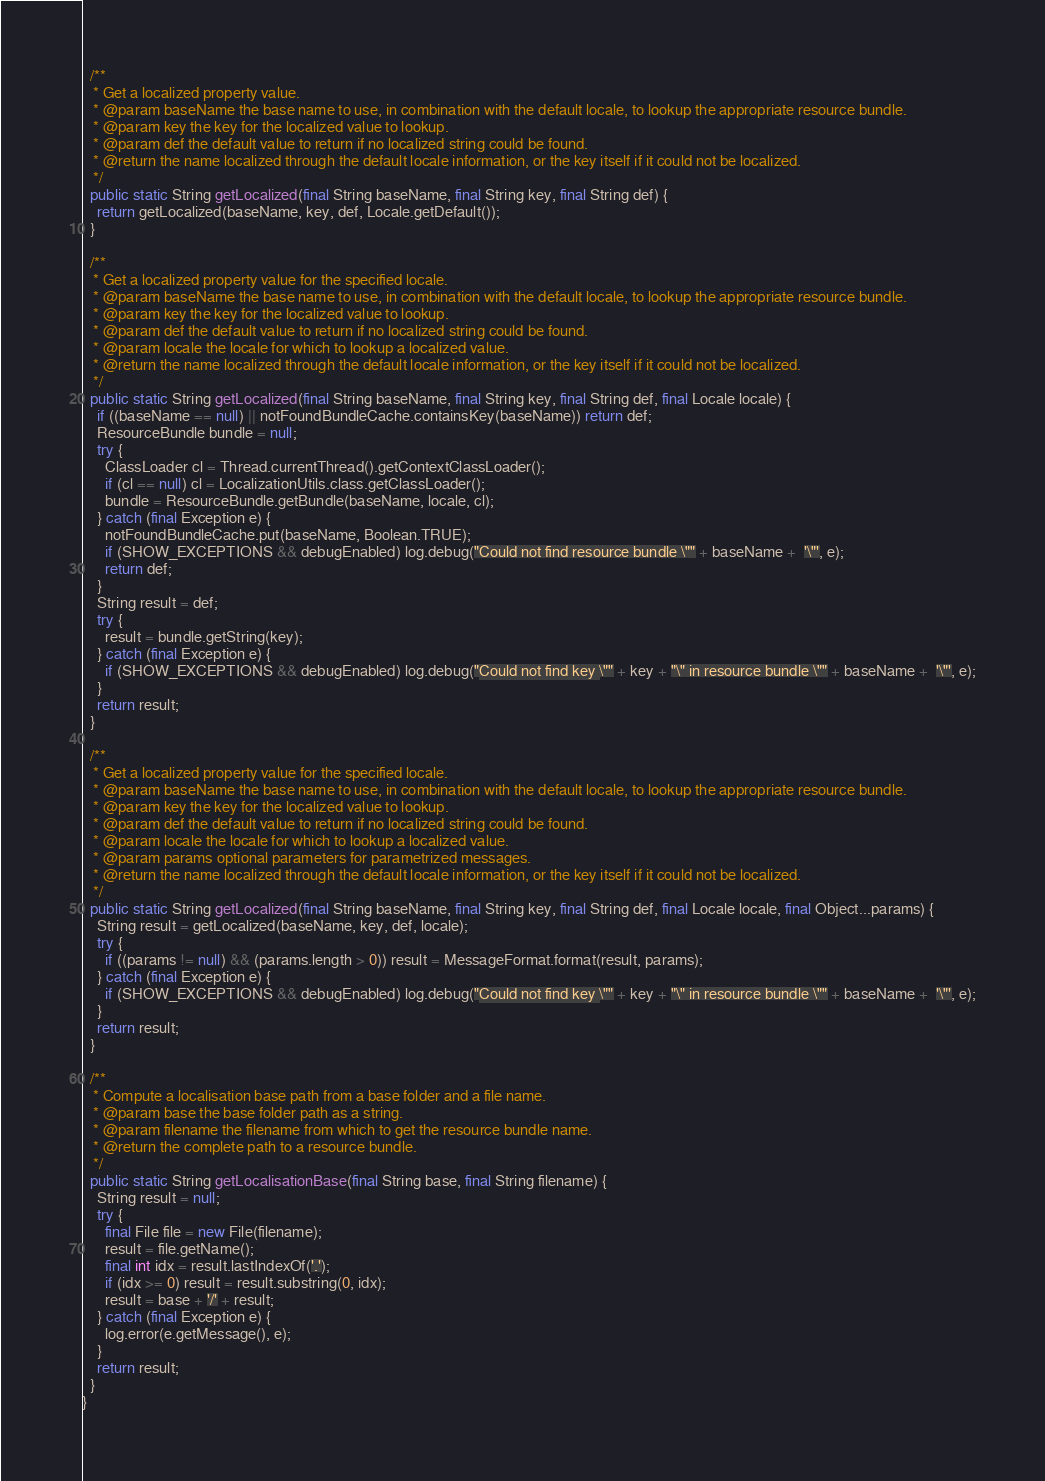<code> <loc_0><loc_0><loc_500><loc_500><_Java_>
  /**
   * Get a localized property value.
   * @param baseName the base name to use, in combination with the default locale, to lookup the appropriate resource bundle.
   * @param key the key for the localized value to lookup.
   * @param def the default value to return if no localized string could be found.
   * @return the name localized through the default locale information, or the key itself if it could not be localized.
   */
  public static String getLocalized(final String baseName, final String key, final String def) {
    return getLocalized(baseName, key, def, Locale.getDefault());
  }

  /**
   * Get a localized property value for the specified locale.
   * @param baseName the base name to use, in combination with the default locale, to lookup the appropriate resource bundle.
   * @param key the key for the localized value to lookup.
   * @param def the default value to return if no localized string could be found.
   * @param locale the locale for which to lookup a localized value.
   * @return the name localized through the default locale information, or the key itself if it could not be localized.
   */
  public static String getLocalized(final String baseName, final String key, final String def, final Locale locale) {
    if ((baseName == null) || notFoundBundleCache.containsKey(baseName)) return def;
    ResourceBundle bundle = null;
    try {
      ClassLoader cl = Thread.currentThread().getContextClassLoader();
      if (cl == null) cl = LocalizationUtils.class.getClassLoader();
      bundle = ResourceBundle.getBundle(baseName, locale, cl);
    } catch (final Exception e) {
      notFoundBundleCache.put(baseName, Boolean.TRUE);
      if (SHOW_EXCEPTIONS && debugEnabled) log.debug("Could not find resource bundle \"" + baseName +  '\"', e);
      return def;
    }
    String result = def;
    try {
      result = bundle.getString(key);
    } catch (final Exception e) {
      if (SHOW_EXCEPTIONS && debugEnabled) log.debug("Could not find key \"" + key + "\" in resource bundle \"" + baseName +  '\"', e);
    }
    return result;
  }

  /**
   * Get a localized property value for the specified locale.
   * @param baseName the base name to use, in combination with the default locale, to lookup the appropriate resource bundle.
   * @param key the key for the localized value to lookup.
   * @param def the default value to return if no localized string could be found.
   * @param locale the locale for which to lookup a localized value.
   * @param params optional parameters for parametrized messages.
   * @return the name localized through the default locale information, or the key itself if it could not be localized.
   */
  public static String getLocalized(final String baseName, final String key, final String def, final Locale locale, final Object...params) {
    String result = getLocalized(baseName, key, def, locale);
    try {
      if ((params != null) && (params.length > 0)) result = MessageFormat.format(result, params);
    } catch (final Exception e) {
      if (SHOW_EXCEPTIONS && debugEnabled) log.debug("Could not find key \"" + key + "\" in resource bundle \"" + baseName +  '\"', e);
    }
    return result;
  }

  /**
   * Compute a localisation base path from a base folder and a file name.
   * @param base the base folder path as a string.
   * @param filename the filename from which to get the resource bundle name.
   * @return the complete path to a resource bundle.
   */
  public static String getLocalisationBase(final String base, final String filename) {
    String result = null;
    try {
      final File file = new File(filename);
      result = file.getName();
      final int idx = result.lastIndexOf('.');
      if (idx >= 0) result = result.substring(0, idx);
      result = base + '/' + result;
    } catch (final Exception e) {
      log.error(e.getMessage(), e);
    }
    return result;
  }
}
</code> 